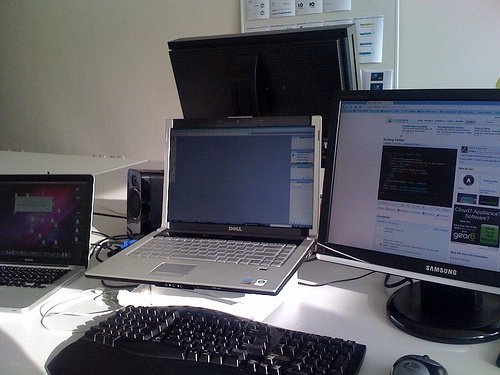Describe the objects in this image and their specific colors. I can see tv in gray, black, and darkgray tones, laptop in gray and black tones, tv in gray, black, and darkblue tones, tv in gray and black tones, and keyboard in gray, black, and darkgray tones in this image. 